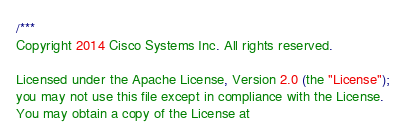<code> <loc_0><loc_0><loc_500><loc_500><_Go_>/***
Copyright 2014 Cisco Systems Inc. All rights reserved.

Licensed under the Apache License, Version 2.0 (the "License");
you may not use this file except in compliance with the License.
You may obtain a copy of the License at</code> 